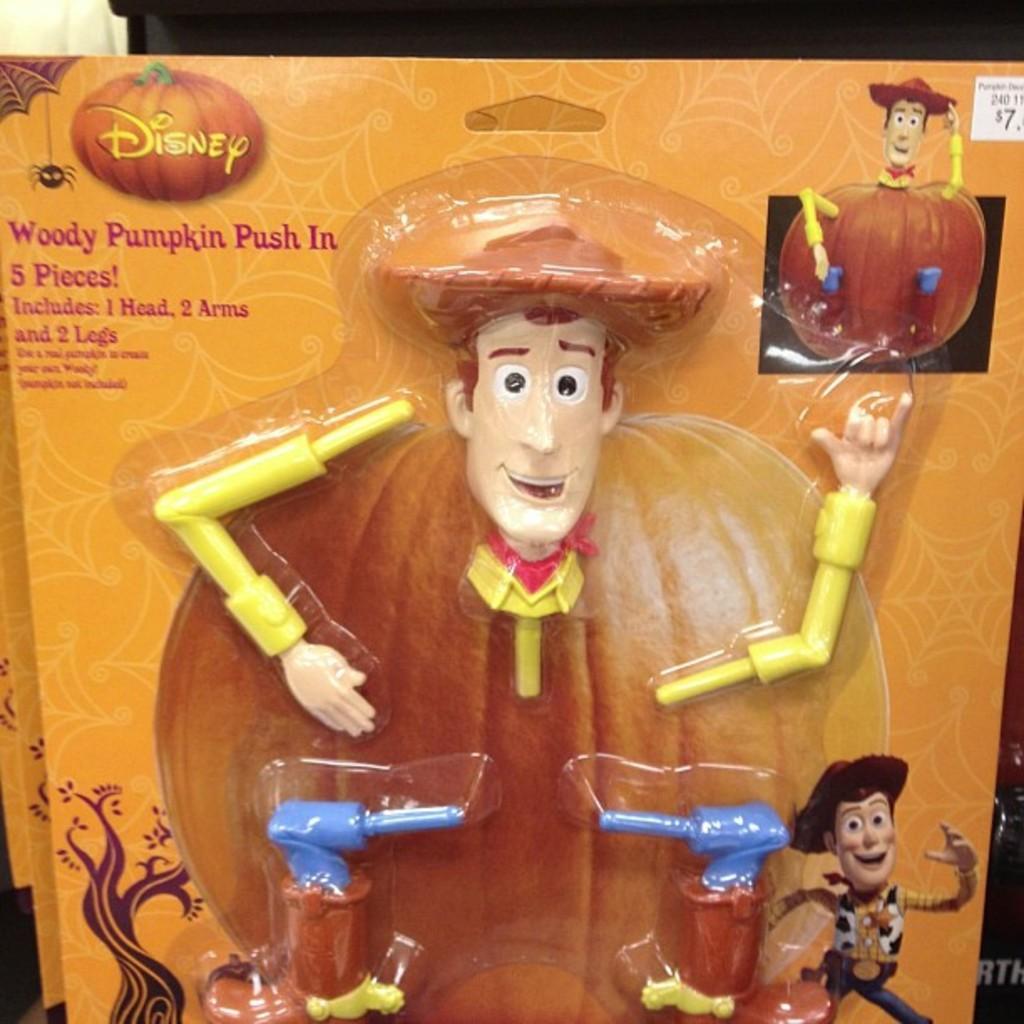Could you give a brief overview of what you see in this image? This is a poster and in this poster we can see a toy parts, tree, pumpkin and some text. 